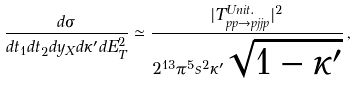Convert formula to latex. <formula><loc_0><loc_0><loc_500><loc_500>\frac { d \sigma } { d t _ { 1 } d t _ { 2 } d y _ { X } d \kappa ^ { \prime } d E _ { T } ^ { 2 } } \simeq \frac { | T ^ { U n i t . } _ { p p \to p j j p } | ^ { 2 } } { 2 ^ { 1 3 } \pi ^ { 5 } s ^ { 2 } \kappa ^ { \prime } \sqrt { 1 - \kappa ^ { \prime } } } \, ,</formula> 